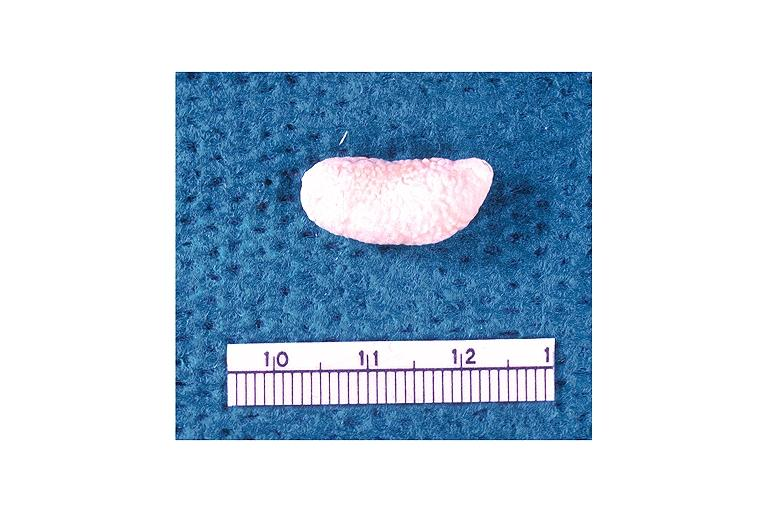what is present?
Answer the question using a single word or phrase. Oral 